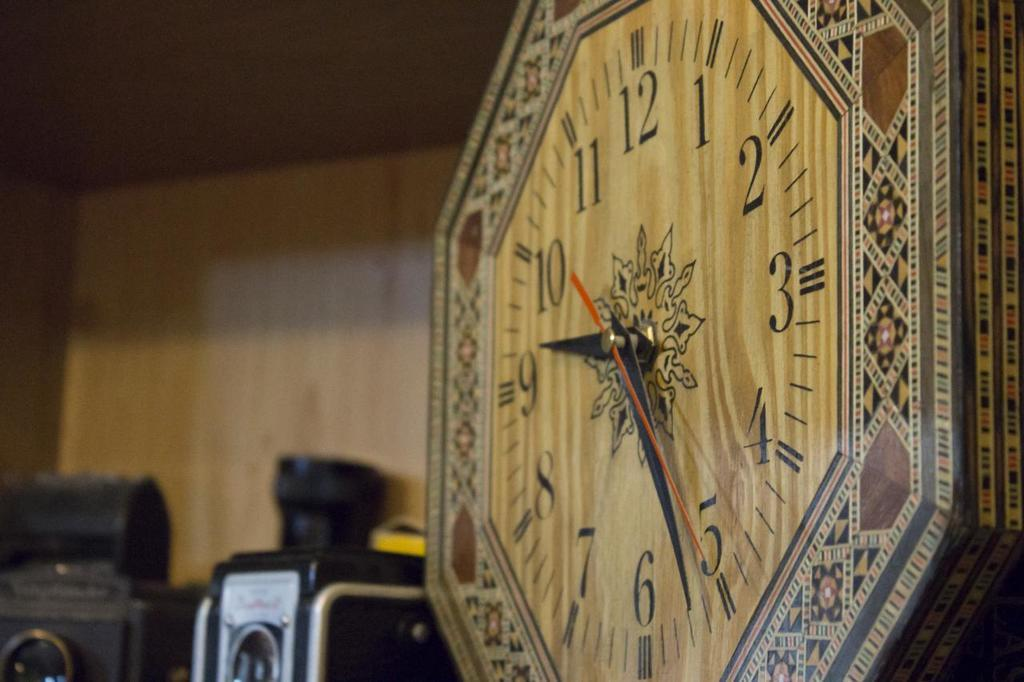<image>
Relay a brief, clear account of the picture shown. A wooden clock with the numbers 1-12 on it. 